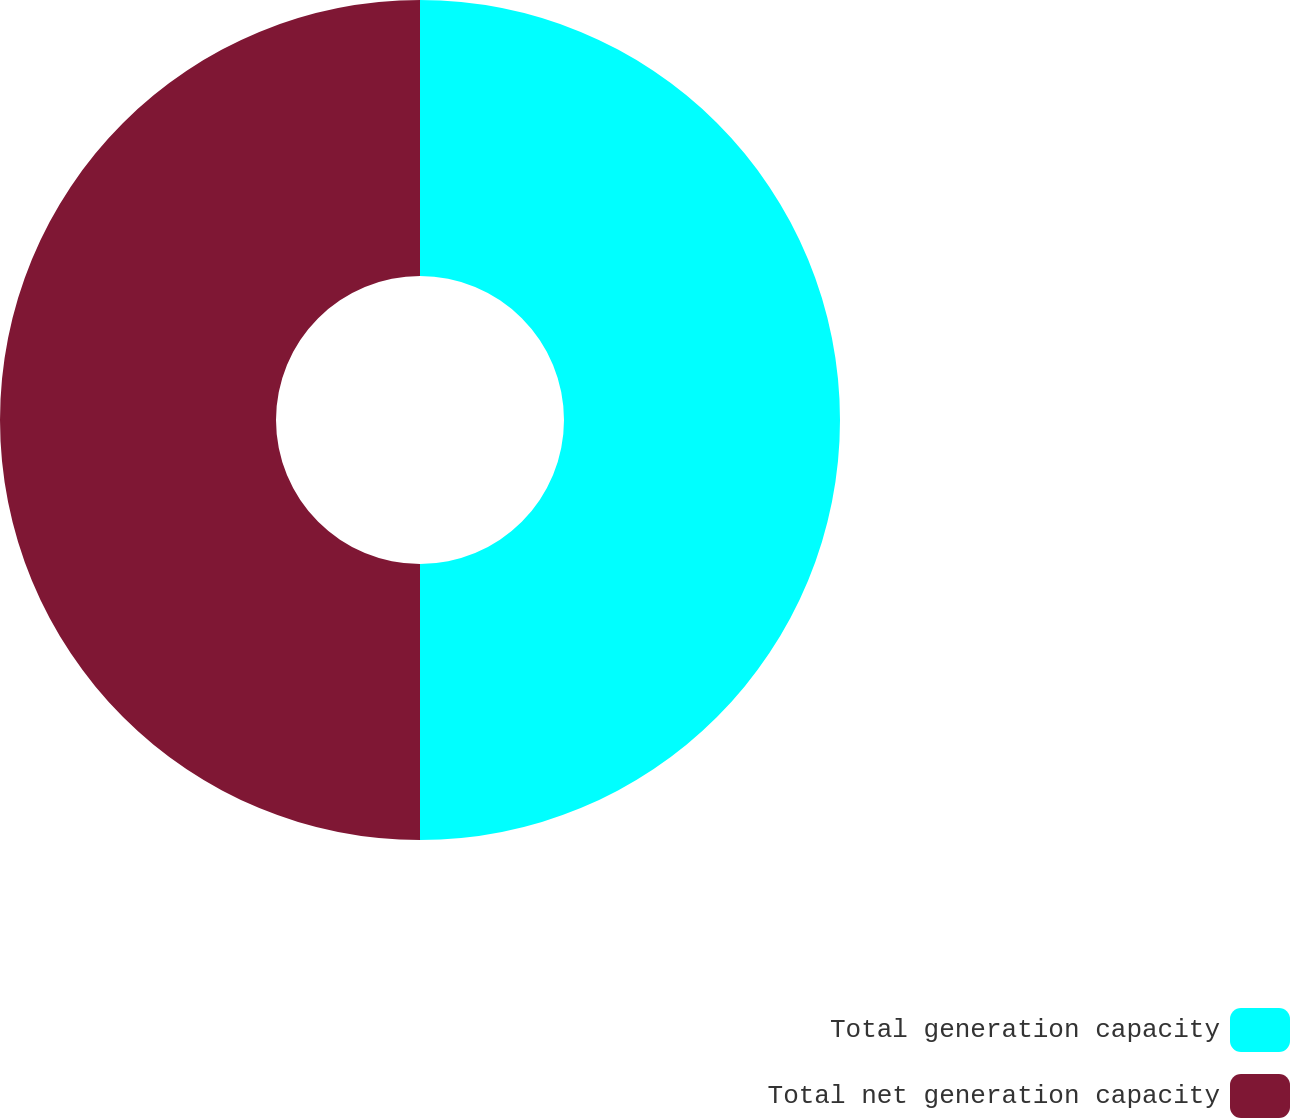Convert chart. <chart><loc_0><loc_0><loc_500><loc_500><pie_chart><fcel>Total generation capacity<fcel>Total net generation capacity<nl><fcel>50.0%<fcel>50.0%<nl></chart> 